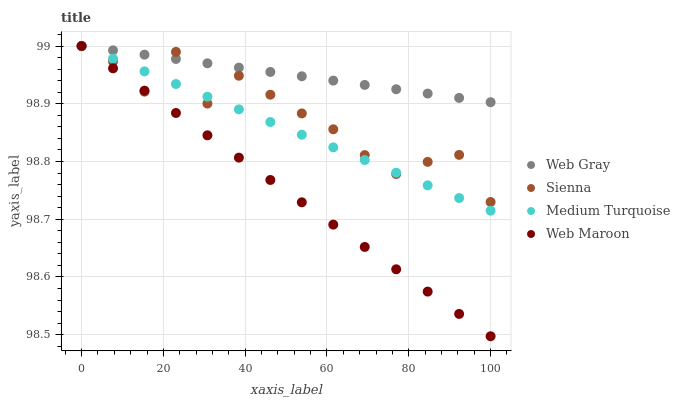Does Web Maroon have the minimum area under the curve?
Answer yes or no. Yes. Does Web Gray have the maximum area under the curve?
Answer yes or no. Yes. Does Web Gray have the minimum area under the curve?
Answer yes or no. No. Does Web Maroon have the maximum area under the curve?
Answer yes or no. No. Is Web Maroon the smoothest?
Answer yes or no. Yes. Is Sienna the roughest?
Answer yes or no. Yes. Is Web Gray the smoothest?
Answer yes or no. No. Is Web Gray the roughest?
Answer yes or no. No. Does Web Maroon have the lowest value?
Answer yes or no. Yes. Does Web Gray have the lowest value?
Answer yes or no. No. Does Medium Turquoise have the highest value?
Answer yes or no. Yes. Does Web Maroon intersect Medium Turquoise?
Answer yes or no. Yes. Is Web Maroon less than Medium Turquoise?
Answer yes or no. No. Is Web Maroon greater than Medium Turquoise?
Answer yes or no. No. 